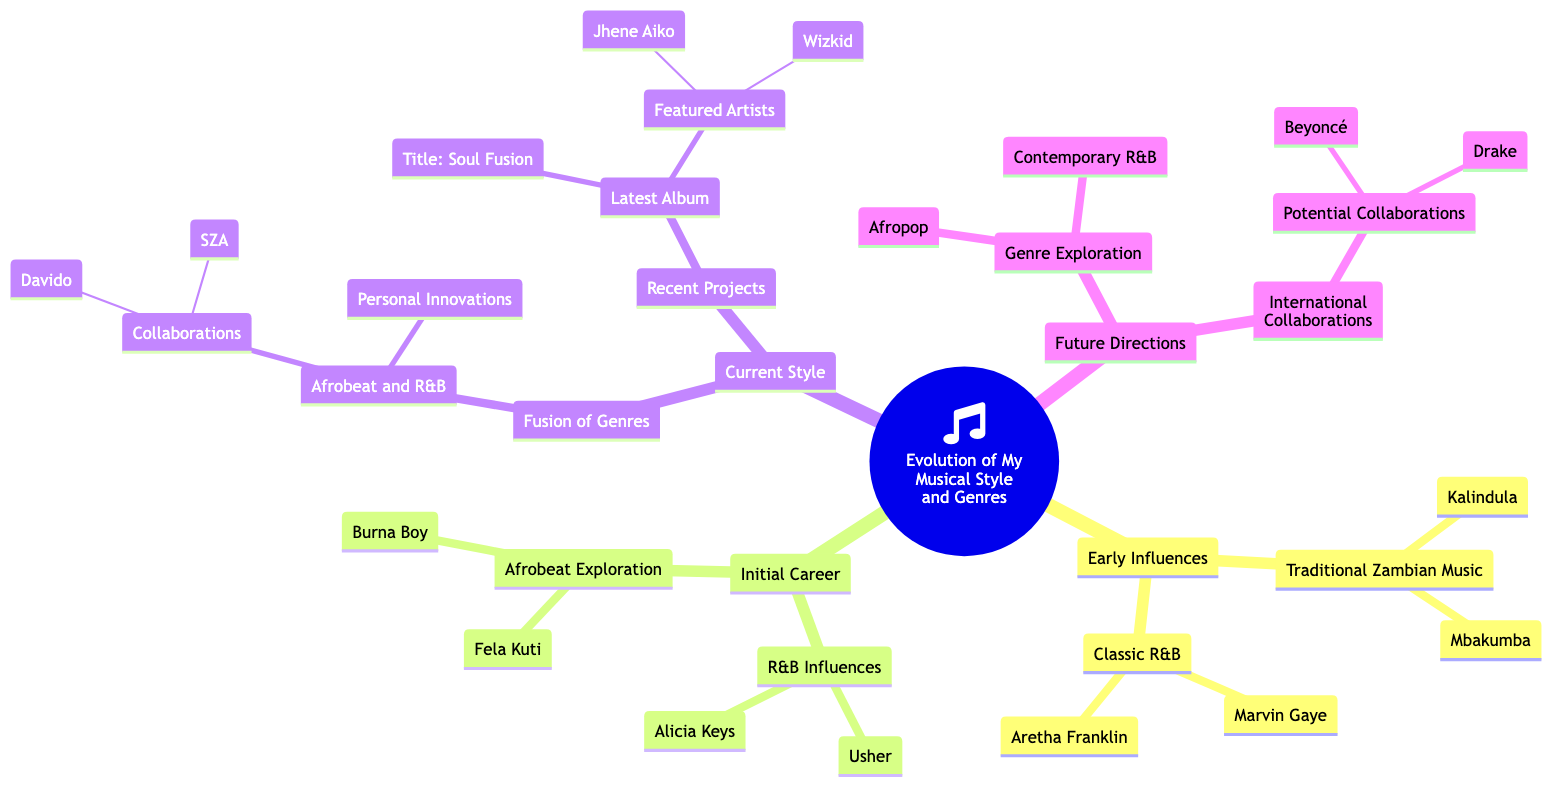What are the two early influences on your musical style? The diagram shows two main categories under "Early Influences": "Traditional Zambian Music" and "Classic R&B".
Answer: Traditional Zambian Music, Classic R&B Who are the two classic R&B artists listed as influences? Under the "Classic R&B" node, the diagram specifies two artists: "Marvin Gaye" and "Aretha Franklin".
Answer: Marvin Gaye, Aretha Franklin How many genres are explored in the "Future Directions"? The "Future Directions" category has two main nodes: "Genre Exploration" and "International Collaborations", indicating two distinct genre directions.
Answer: 2 Which genres are highlighted under "Genre Exploration"? Inside the "Genre Exploration" node, the diagram lists two genres: "Afropop" and "Contemporary R&B".
Answer: Afropop, Contemporary R&B What recent project title is mentioned in your current style? The "Latest Album" node under "Recent Projects" specifies the title "Soul Fusion".
Answer: Soul Fusion Who are the featured artists on your latest album? In the "Featured Artists" section under "Latest Album", two artists are mentioned: "Wizkid" and "Jhene Aiko".
Answer: Wizkid, Jhene Aiko Which artist represents the Afrobeat influences during your initial career? The "Afrobeat Exploration" node under "Initial Career" lists "Fela Kuti" and "Burna Boy" as key influences in that genre.
Answer: Fela Kuti, Burna Boy How many artists are noted as potential international collaborations? The "International Collaborations" section under "Future Directions" has a node "Potential Collaborations" that mentions two artists: "Beyoncé" and "Drake".
Answer: 2 What two elements are combined in your current style under "Fusion of Genres"? The "Fusion of Genres" node states that you blend "Afrobeat and R&B" in your current musical style.
Answer: Afrobeat and R&B 